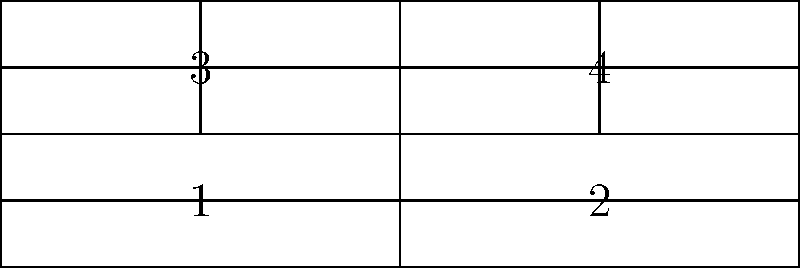Consider a surface formed by interconnecting four card catalog drawers as shown in the diagram. The drawers are connected along their edges, creating a closed surface. Determine the genus of this surface. To determine the genus of the surface, we'll follow these steps:

1. Identify the topological structure:
   The surface is formed by four rectangular drawers connected along their edges.

2. Count the number of vertices (V):
   There are 8 vertices where the corners of the drawers meet.

3. Count the number of edges (E):
   There are 12 edges in total (4 edges for each drawer, but some are shared).

4. Count the number of faces (F):
   There are 6 faces (4 drawer faces + 2 open ends).

5. Calculate the Euler characteristic (χ):
   χ = V - E + F
   χ = 8 - 12 + 6 = 2

6. Use the Euler-Poincaré formula to find the genus (g):
   χ = 2 - 2g
   2 = 2 - 2g
   2g = 0
   g = 0

Therefore, the genus of the surface is 0.

This means the surface is topologically equivalent to a sphere, which is consistent with the structure of interconnected drawers forming a closed surface without any "handles".
Answer: 0 